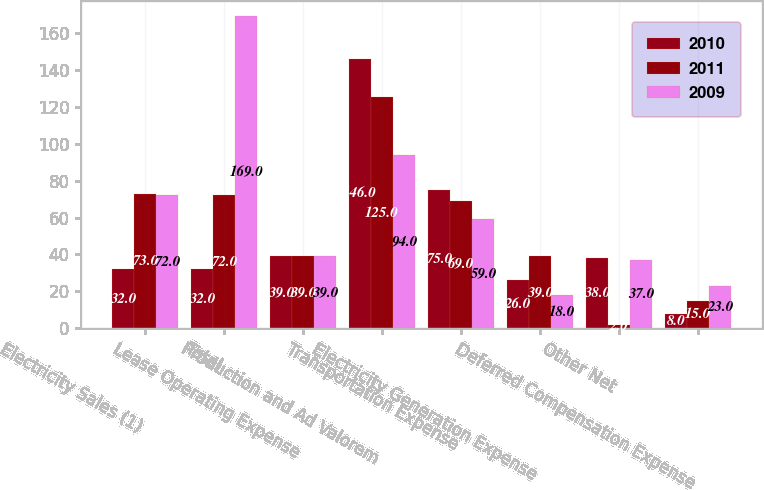<chart> <loc_0><loc_0><loc_500><loc_500><stacked_bar_chart><ecel><fcel>Electricity Sales (1)<fcel>Total<fcel>Lease Operating Expense<fcel>Production and Ad Valorem<fcel>Transportation Expense<fcel>Electricity Generation Expense<fcel>Other Net<fcel>Deferred Compensation Expense<nl><fcel>2010<fcel>32<fcel>32<fcel>39<fcel>146<fcel>75<fcel>26<fcel>38<fcel>8<nl><fcel>2011<fcel>73<fcel>72<fcel>39<fcel>125<fcel>69<fcel>39<fcel>2<fcel>15<nl><fcel>2009<fcel>72<fcel>169<fcel>39<fcel>94<fcel>59<fcel>18<fcel>37<fcel>23<nl></chart> 